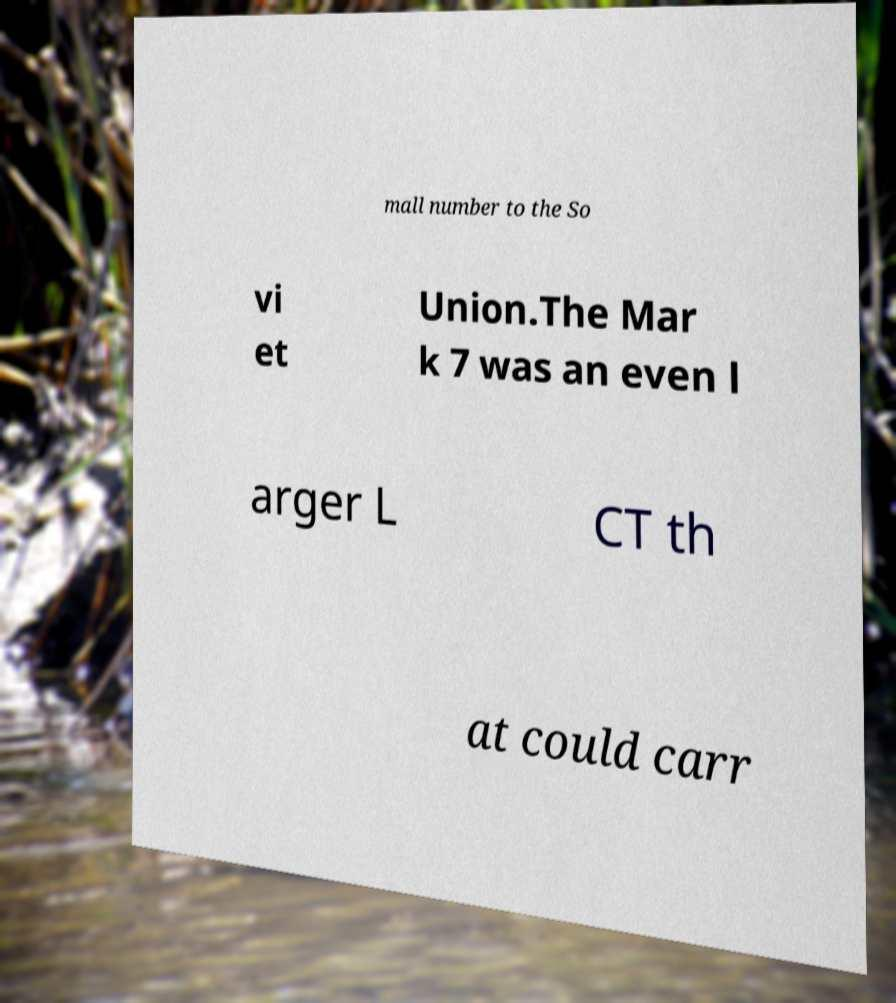I need the written content from this picture converted into text. Can you do that? mall number to the So vi et Union.The Mar k 7 was an even l arger L CT th at could carr 